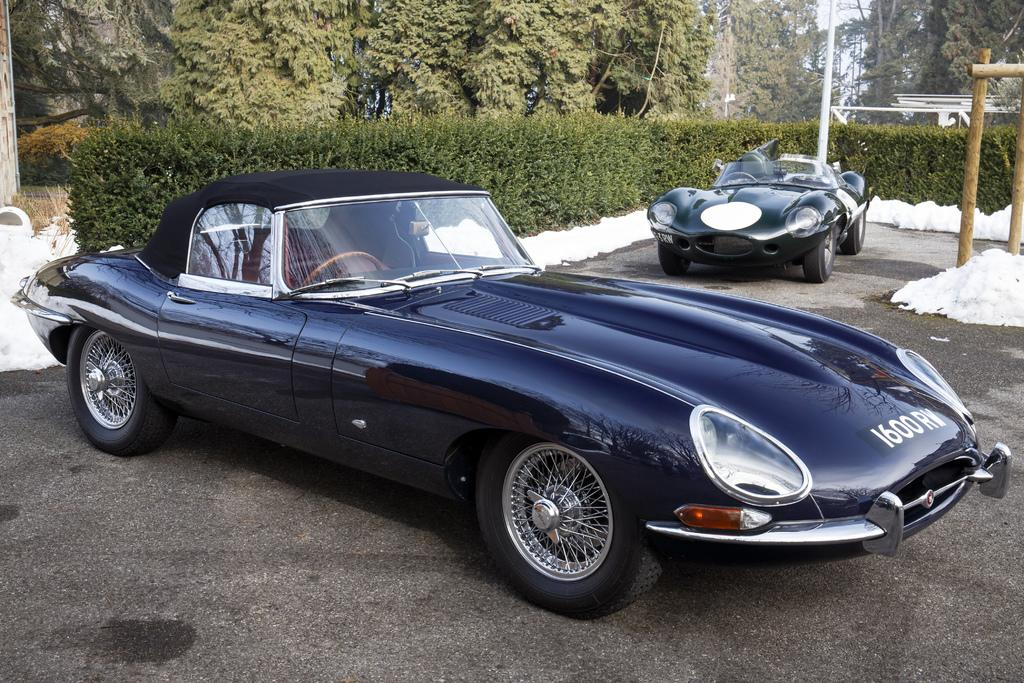What are the main subjects in the center of the image? There are two cars in the center of the image. What can be seen in the background of the image? There are trees, plants, and poles in the background of the image. What type of apparel are the mice wearing in the image? There are no mice present in the image, so it is not possible to determine what type of apparel they might be wearing. 